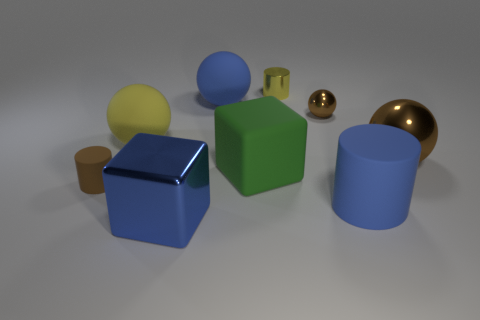Subtract all large balls. How many balls are left? 1 Subtract all blue cylinders. How many cylinders are left? 2 Add 1 small matte objects. How many objects exist? 10 Subtract 1 cylinders. How many cylinders are left? 2 Subtract all blue cylinders. How many brown balls are left? 2 Subtract all small matte spheres. Subtract all small brown metal objects. How many objects are left? 8 Add 4 big rubber cubes. How many big rubber cubes are left? 5 Add 7 tiny metallic things. How many tiny metallic things exist? 9 Subtract 1 yellow spheres. How many objects are left? 8 Subtract all cylinders. How many objects are left? 6 